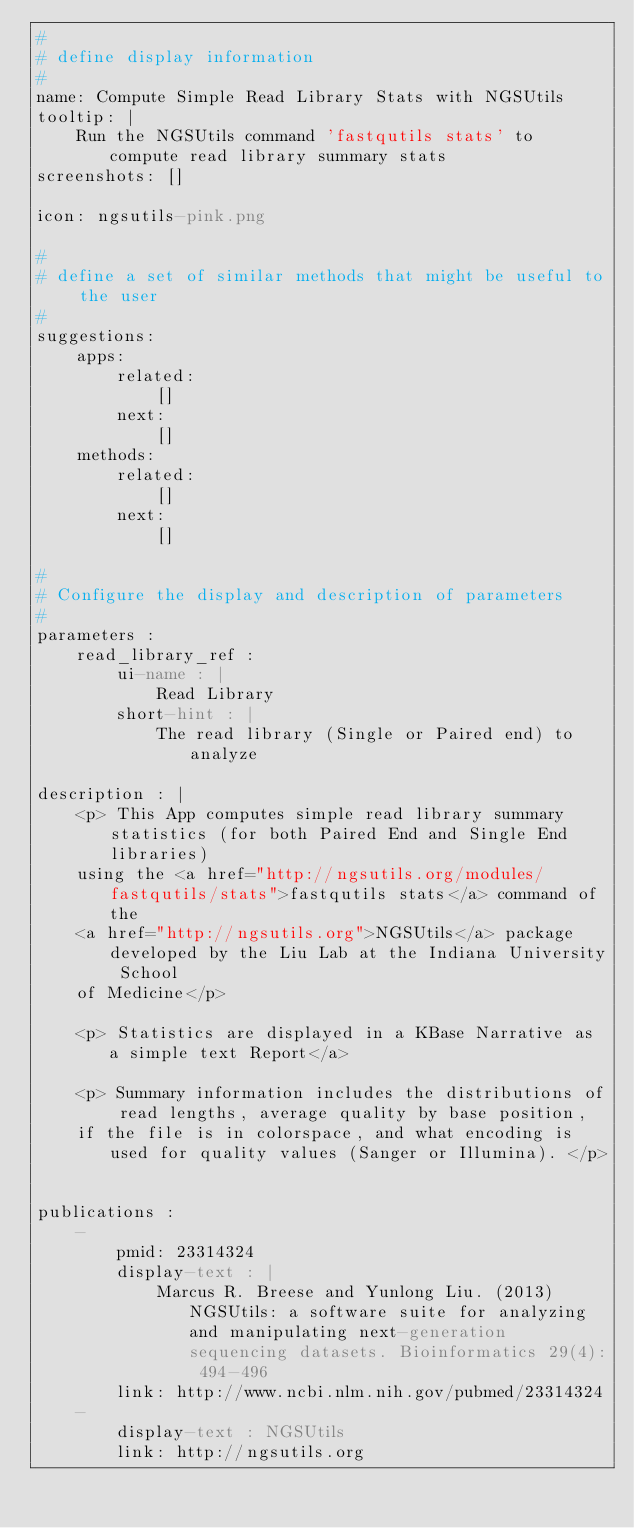<code> <loc_0><loc_0><loc_500><loc_500><_YAML_>#
# define display information
#
name: Compute Simple Read Library Stats with NGSUtils
tooltip: |
    Run the NGSUtils command 'fastqutils stats' to compute read library summary stats
screenshots: []

icon: ngsutils-pink.png

#
# define a set of similar methods that might be useful to the user
#
suggestions:
    apps:
        related:
            []
        next:
            []
    methods:
        related:
            []
        next:
            []

#
# Configure the display and description of parameters
#
parameters :
    read_library_ref :
        ui-name : |
            Read Library
        short-hint : |
            The read library (Single or Paired end) to analyze

description : |
    <p> This App computes simple read library summary statistics (for both Paired End and Single End libraries)
    using the <a href="http://ngsutils.org/modules/fastqutils/stats">fastqutils stats</a> command of the
    <a href="http://ngsutils.org">NGSUtils</a> package developed by the Liu Lab at the Indiana University School
    of Medicine</p>

    <p> Statistics are displayed in a KBase Narrative as a simple text Report</a>

    <p> Summary information includes the distributions of read lengths, average quality by base position,
    if the file is in colorspace, and what encoding is used for quality values (Sanger or Illumina). </p>


publications :
    -
        pmid: 23314324
        display-text : |
            Marcus R. Breese and Yunlong Liu. (2013) NGSUtils: a software suite for analyzing and manipulating next-generation sequencing datasets. Bioinformatics 29(4): 494-496
        link: http://www.ncbi.nlm.nih.gov/pubmed/23314324
    -
        display-text : NGSUtils 
        link: http://ngsutils.org


</code> 